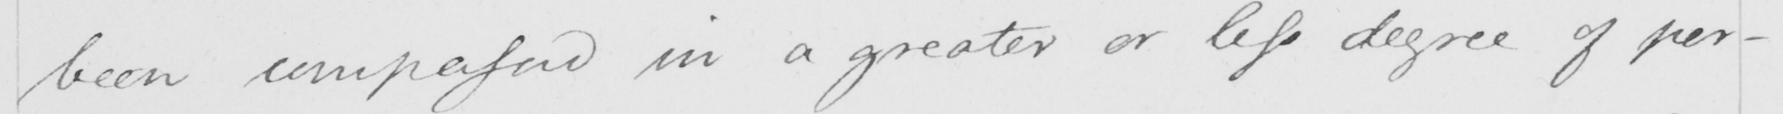Please transcribe the handwritten text in this image. been compassed in a greater or less degree of per- 